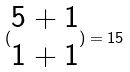Convert formula to latex. <formula><loc_0><loc_0><loc_500><loc_500>( \begin{matrix} 5 + 1 \\ 1 + 1 \end{matrix} ) = 1 5</formula> 